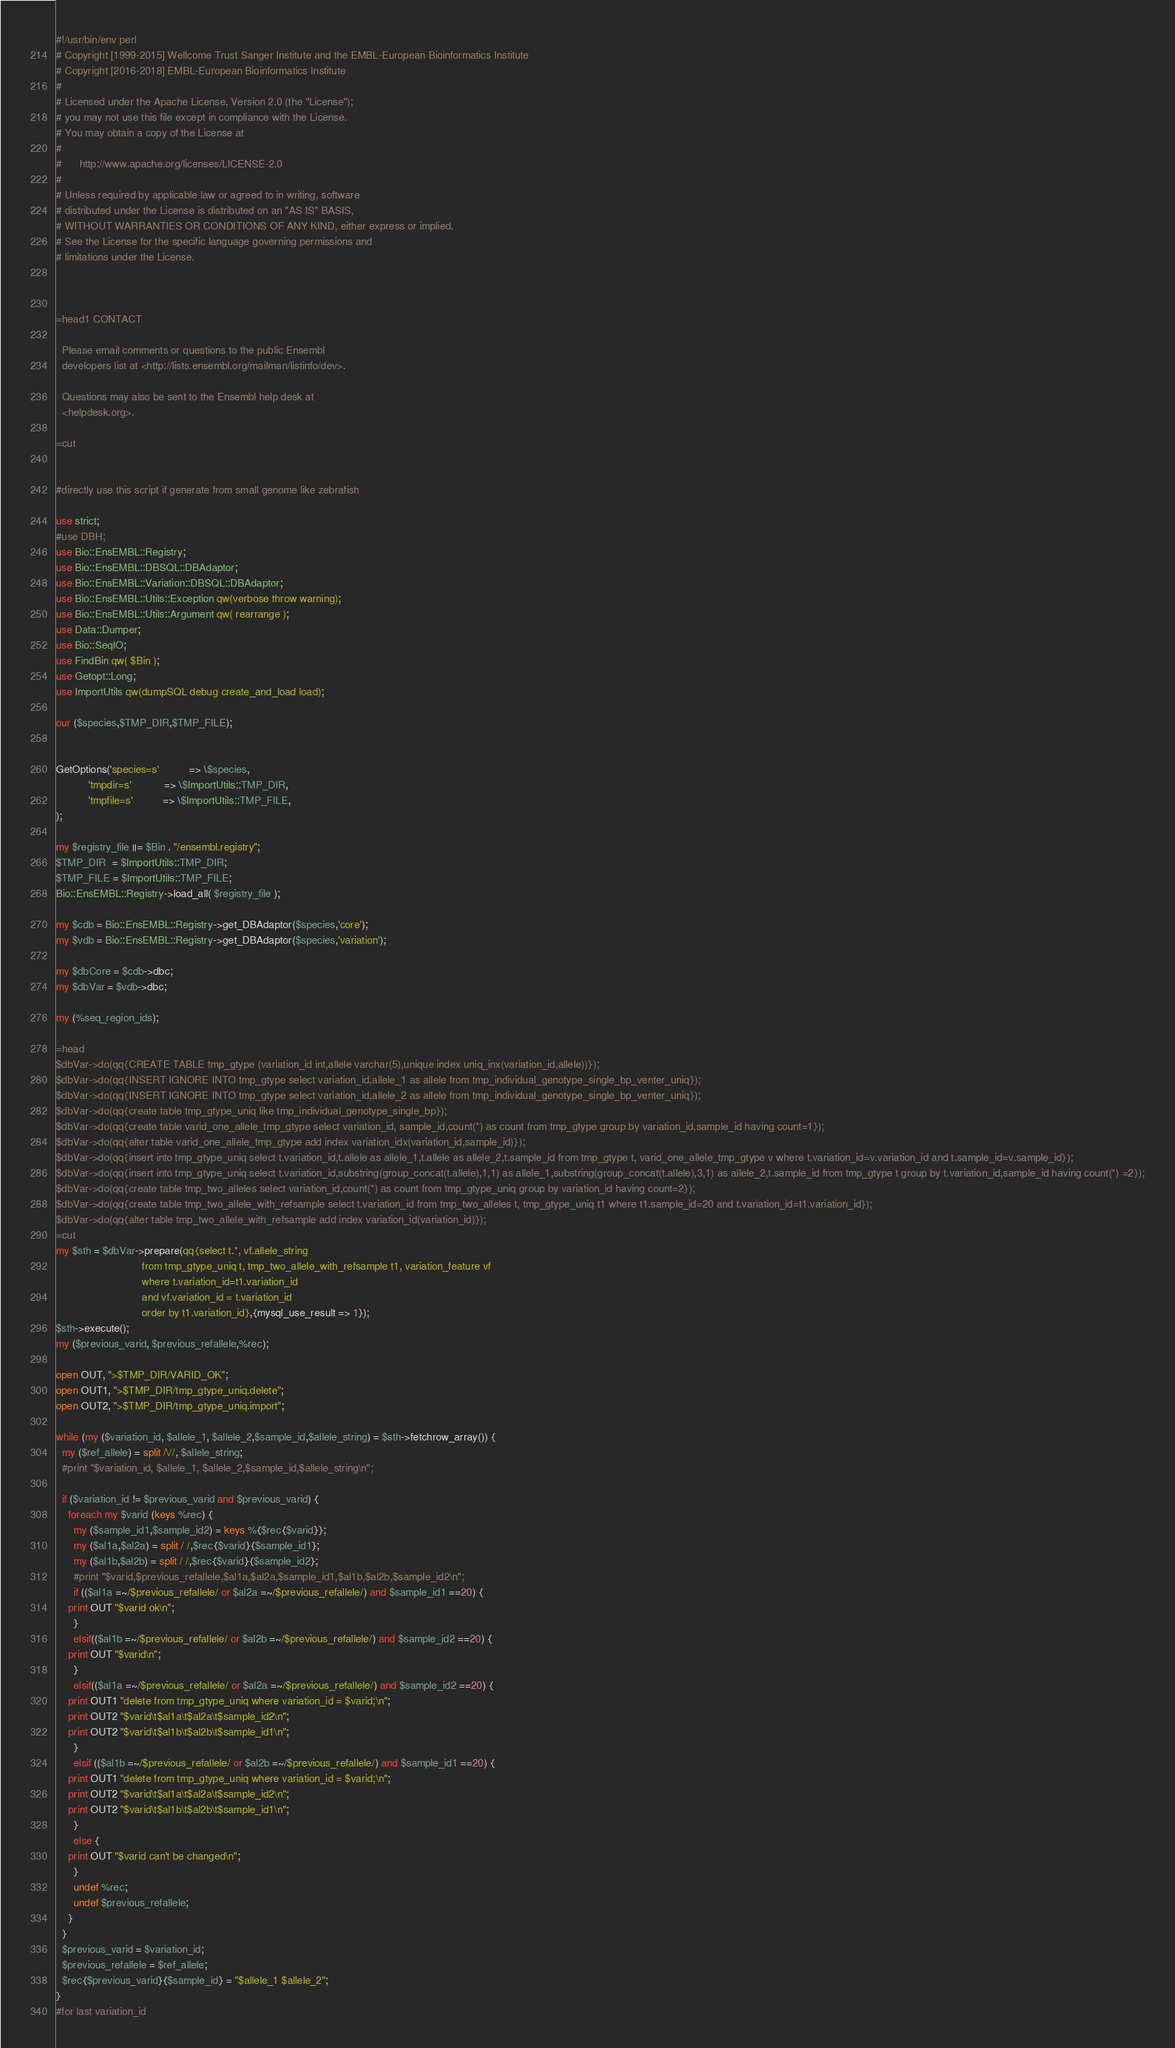<code> <loc_0><loc_0><loc_500><loc_500><_Perl_>#!/usr/bin/env perl
# Copyright [1999-2015] Wellcome Trust Sanger Institute and the EMBL-European Bioinformatics Institute
# Copyright [2016-2018] EMBL-European Bioinformatics Institute
# 
# Licensed under the Apache License, Version 2.0 (the "License");
# you may not use this file except in compliance with the License.
# You may obtain a copy of the License at
# 
#      http://www.apache.org/licenses/LICENSE-2.0
# 
# Unless required by applicable law or agreed to in writing, software
# distributed under the License is distributed on an "AS IS" BASIS,
# WITHOUT WARRANTIES OR CONDITIONS OF ANY KIND, either express or implied.
# See the License for the specific language governing permissions and
# limitations under the License.



=head1 CONTACT

  Please email comments or questions to the public Ensembl
  developers list at <http://lists.ensembl.org/mailman/listinfo/dev>.

  Questions may also be sent to the Ensembl help desk at
  <helpdesk.org>.

=cut


#directly use this script if generate from small genome like zebrafish

use strict;
#use DBH;
use Bio::EnsEMBL::Registry;
use Bio::EnsEMBL::DBSQL::DBAdaptor;
use Bio::EnsEMBL::Variation::DBSQL::DBAdaptor;
use Bio::EnsEMBL::Utils::Exception qw(verbose throw warning);
use Bio::EnsEMBL::Utils::Argument qw( rearrange );
use Data::Dumper;
use Bio::SeqIO;
use FindBin qw( $Bin );
use Getopt::Long;
use ImportUtils qw(dumpSQL debug create_and_load load);

our ($species,$TMP_DIR,$TMP_FILE);


GetOptions('species=s'          => \$species,
           'tmpdir=s'           => \$ImportUtils::TMP_DIR,
           'tmpfile=s'          => \$ImportUtils::TMP_FILE,
);

my $registry_file ||= $Bin . "/ensembl.registry";
$TMP_DIR  = $ImportUtils::TMP_DIR;
$TMP_FILE = $ImportUtils::TMP_FILE;
Bio::EnsEMBL::Registry->load_all( $registry_file );

my $cdb = Bio::EnsEMBL::Registry->get_DBAdaptor($species,'core');
my $vdb = Bio::EnsEMBL::Registry->get_DBAdaptor($species,'variation');

my $dbCore = $cdb->dbc;
my $dbVar = $vdb->dbc;

my (%seq_region_ids);

=head
$dbVar->do(qq{CREATE TABLE tmp_gtype (variation_id int,allele varchar(5),unique index uniq_inx(variation_id,allele))});
$dbVar->do(qq{INSERT IGNORE INTO tmp_gtype select variation_id,allele_1 as allele from tmp_individual_genotype_single_bp_venter_uniq});
$dbVar->do(qq{INSERT IGNORE INTO tmp_gtype select variation_id,allele_2 as allele from tmp_individual_genotype_single_bp_venter_uniq});
$dbVar->do(qq{create table tmp_gtype_uniq like tmp_individual_genotype_single_bp});
$dbVar->do(qq{create table varid_one_allele_tmp_gtype select variation_id, sample_id,count(*) as count from tmp_gtype group by variation_id,sample_id having count=1});
$dbVar->do(qq{alter table varid_one_allele_tmp_gtype add index variation_idx(variation_id,sample_id)});
$dbVar->do(qq{insert into tmp_gtype_uniq select t.variation_id,t.allele as allele_1,t.allele as allele_2,t.sample_id from tmp_gtype t, varid_one_allele_tmp_gtype v where t.variation_id=v.variation_id and t.sample_id=v.sample_id});
$dbVar->do(qq{insert into tmp_gtype_uniq select t.variation_id,substring(group_concat(t.allele),1,1) as allele_1,substring(group_concat(t.allele),3,1) as allele_2,t.sample_id from tmp_gtype t group by t.variation_id,sample_id having count(*) =2});
$dbVar->do(qq{create table tmp_two_alleles select variation_id,count(*) as count from tmp_gtype_uniq group by variation_id having count=2});
$dbVar->do(qq{create table tmp_two_allele_with_refsample select t.variation_id from tmp_two_alleles t, tmp_gtype_uniq t1 where t1.sample_id=20 and t.variation_id=t1.variation_id});
$dbVar->do(qq{alter table tmp_two_allele_with_refsample add index variation_id(variation_id)});
=cut
my $sth = $dbVar->prepare(qq{select t.*, vf.allele_string 
                             from tmp_gtype_uniq t, tmp_two_allele_with_refsample t1, variation_feature vf
                             where t.variation_id=t1.variation_id
                             and vf.variation_id = t.variation_id 
                             order by t1.variation_id},{mysql_use_result => 1});
$sth->execute();
my ($previous_varid, $previous_refallele,%rec);

open OUT, ">$TMP_DIR/VARID_OK";
open OUT1, ">$TMP_DIR/tmp_gtype_uniq.delete";
open OUT2, ">$TMP_DIR/tmp_gtype_uniq.import";

while (my ($variation_id, $allele_1, $allele_2,$sample_id,$allele_string) = $sth->fetchrow_array()) {
  my ($ref_allele) = split /\//, $allele_string;
  #print "$variation_id, $allele_1, $allele_2,$sample_id,$allele_string\n";

  if ($variation_id != $previous_varid and $previous_varid) {
    foreach my $varid (keys %rec) {
      my ($sample_id1,$sample_id2) = keys %{$rec{$varid}};
      my ($al1a,$al2a) = split / /,$rec{$varid}{$sample_id1};
      my ($al1b,$al2b) = split / /,$rec{$varid}{$sample_id2};
      #print "$varid,$previous_refallele,$al1a,$al2a,$sample_id1,$al1b,$al2b,$sample_id2\n";
      if (($al1a =~/$previous_refallele/ or $al2a =~/$previous_refallele/) and $sample_id1 ==20) {
	print OUT "$varid ok\n";
      }
      elsif(($al1b =~/$previous_refallele/ or $al2b =~/$previous_refallele/) and $sample_id2 ==20) {
	print OUT "$varid\n";
      }
      elsif(($al1a =~/$previous_refallele/ or $al2a =~/$previous_refallele/) and $sample_id2 ==20) {
	print OUT1 "delete from tmp_gtype_uniq where variation_id = $varid;\n";
	print OUT2 "$varid\t$al1a\t$al2a\t$sample_id2\n";
	print OUT2 "$varid\t$al1b\t$al2b\t$sample_id1\n";
      }
      elsif (($al1b =~/$previous_refallele/ or $al2b =~/$previous_refallele/) and $sample_id1 ==20) {
	print OUT1 "delete from tmp_gtype_uniq where variation_id = $varid;\n";
	print OUT2 "$varid\t$al1a\t$al2a\t$sample_id2\n";
	print OUT2 "$varid\t$al1b\t$al2b\t$sample_id1\n";
      }
      else {
	print OUT "$varid can't be changed\n";
      }
      undef %rec;
      undef $previous_refallele;
    }
  }
  $previous_varid = $variation_id;
  $previous_refallele = $ref_allele;
  $rec{$previous_varid}{$sample_id} = "$allele_1 $allele_2";
}
#for last variation_id</code> 